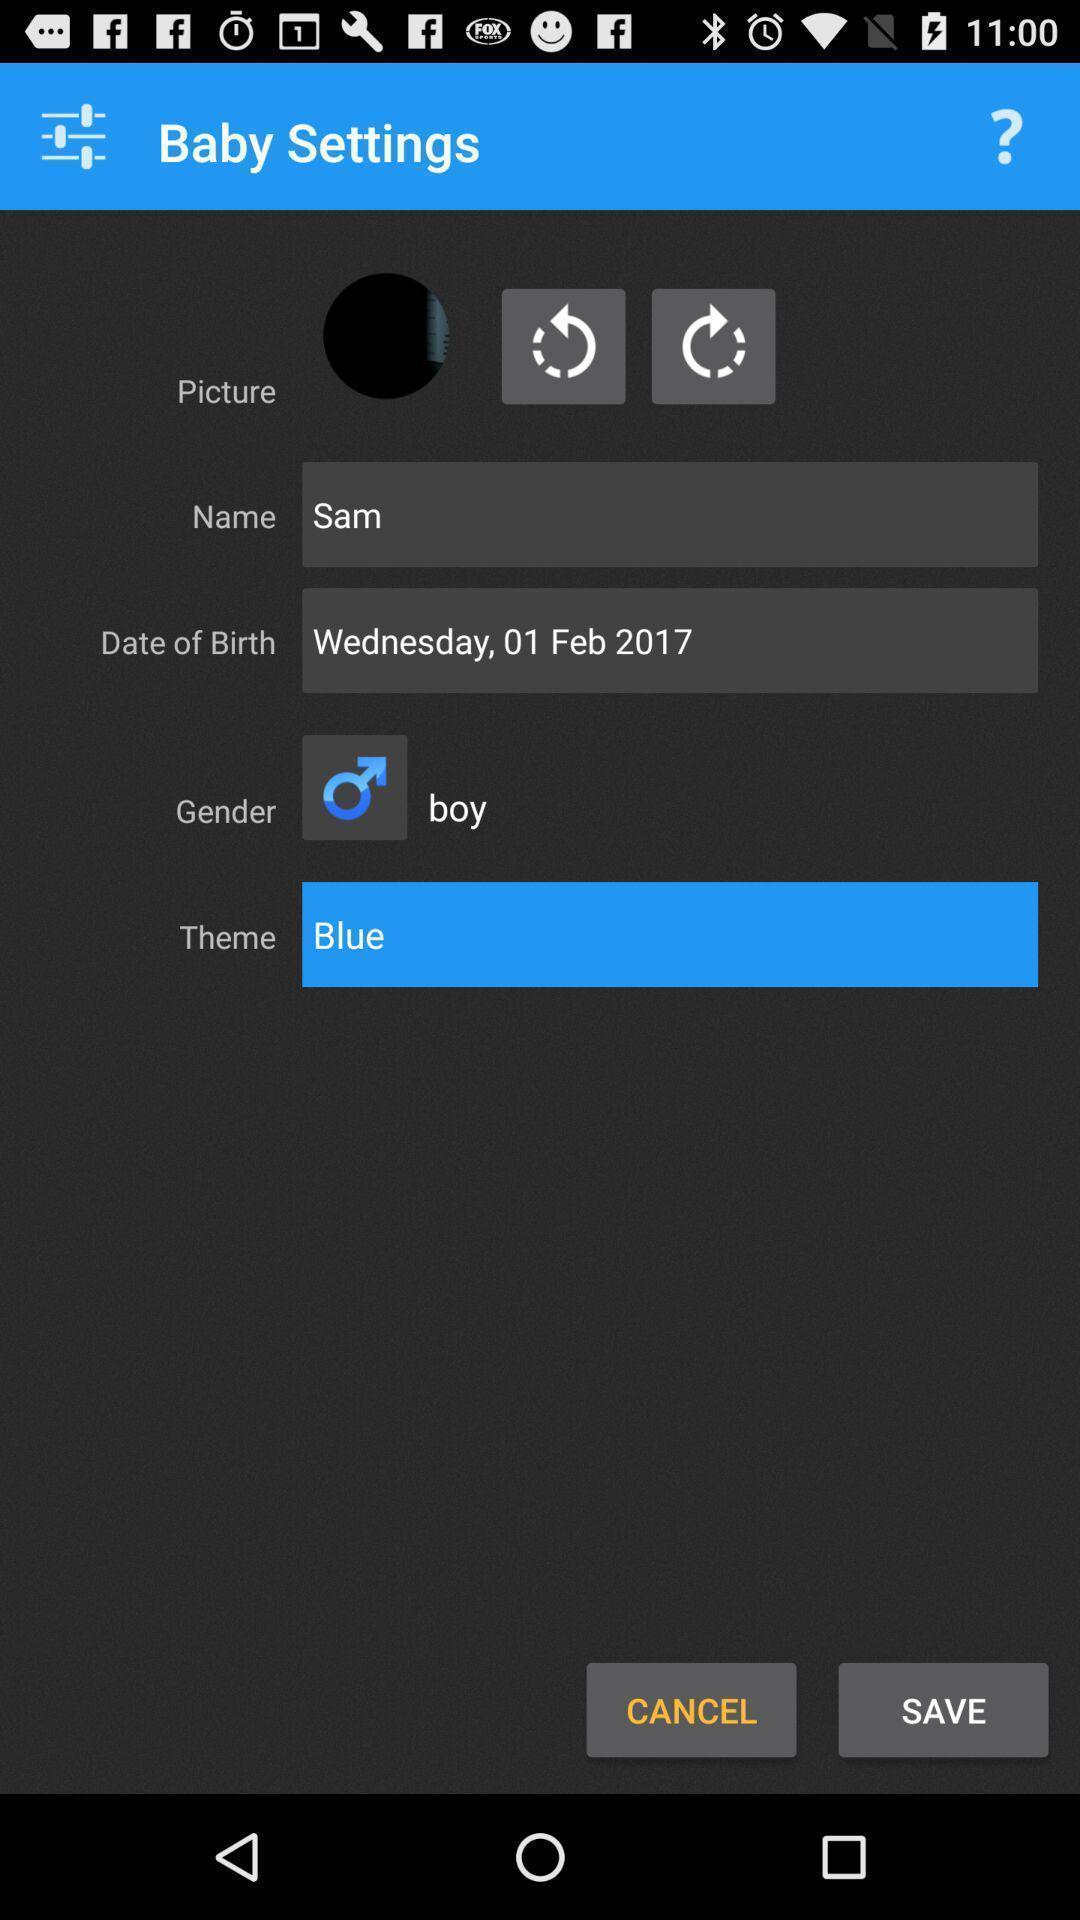Explain the elements present in this screenshot. Screen displaying the settings page. 